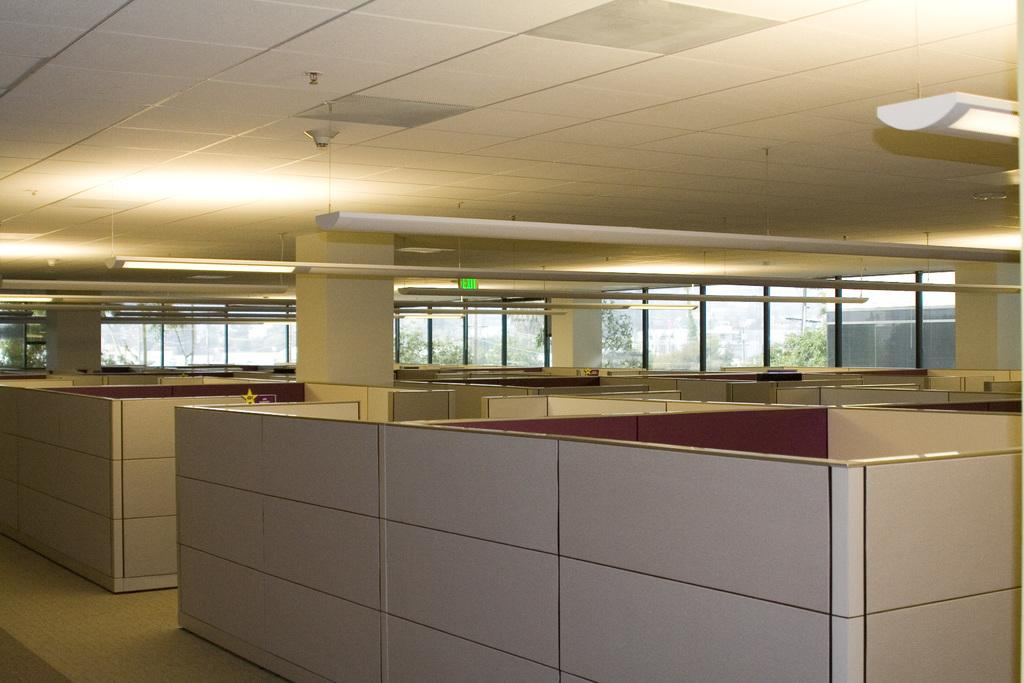What type of structures are on the floor in the image? There are many cabins on the floor in the image. What separates the cabins from each other? There are pillars between the cabins. What can be seen in the background of the image? There are windows in the background. What type of boot is being worn by the uncle in the image? There is no uncle or boot present in the image. What type of hose is connected to the cabin in the image? There is no hose connected to the cabins in the image. 